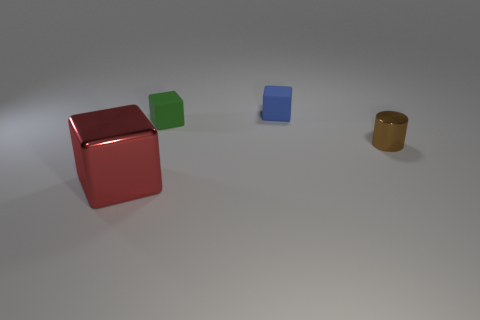Is there any other thing that has the same color as the tiny metallic object?
Offer a very short reply. No. There is a metal thing behind the shiny object in front of the small cylinder; are there any cubes that are in front of it?
Keep it short and to the point. Yes. The small shiny cylinder is what color?
Offer a very short reply. Brown. There is a small brown object; are there any tiny blue rubber blocks right of it?
Offer a very short reply. No. Does the brown thing have the same shape as the metallic object in front of the metallic cylinder?
Make the answer very short. No. What number of other things are there of the same material as the red object
Give a very brief answer. 1. There is a cube in front of the metal object that is on the right side of the block that is in front of the metallic cylinder; what is its color?
Offer a terse response. Red. There is a small metallic object in front of the small block in front of the small blue matte thing; what shape is it?
Your answer should be very brief. Cylinder. Are there more small green cubes to the left of the tiny green matte thing than big blocks?
Provide a succinct answer. No. There is a metal thing that is behind the big metal block; is it the same shape as the big red metallic thing?
Keep it short and to the point. No. 